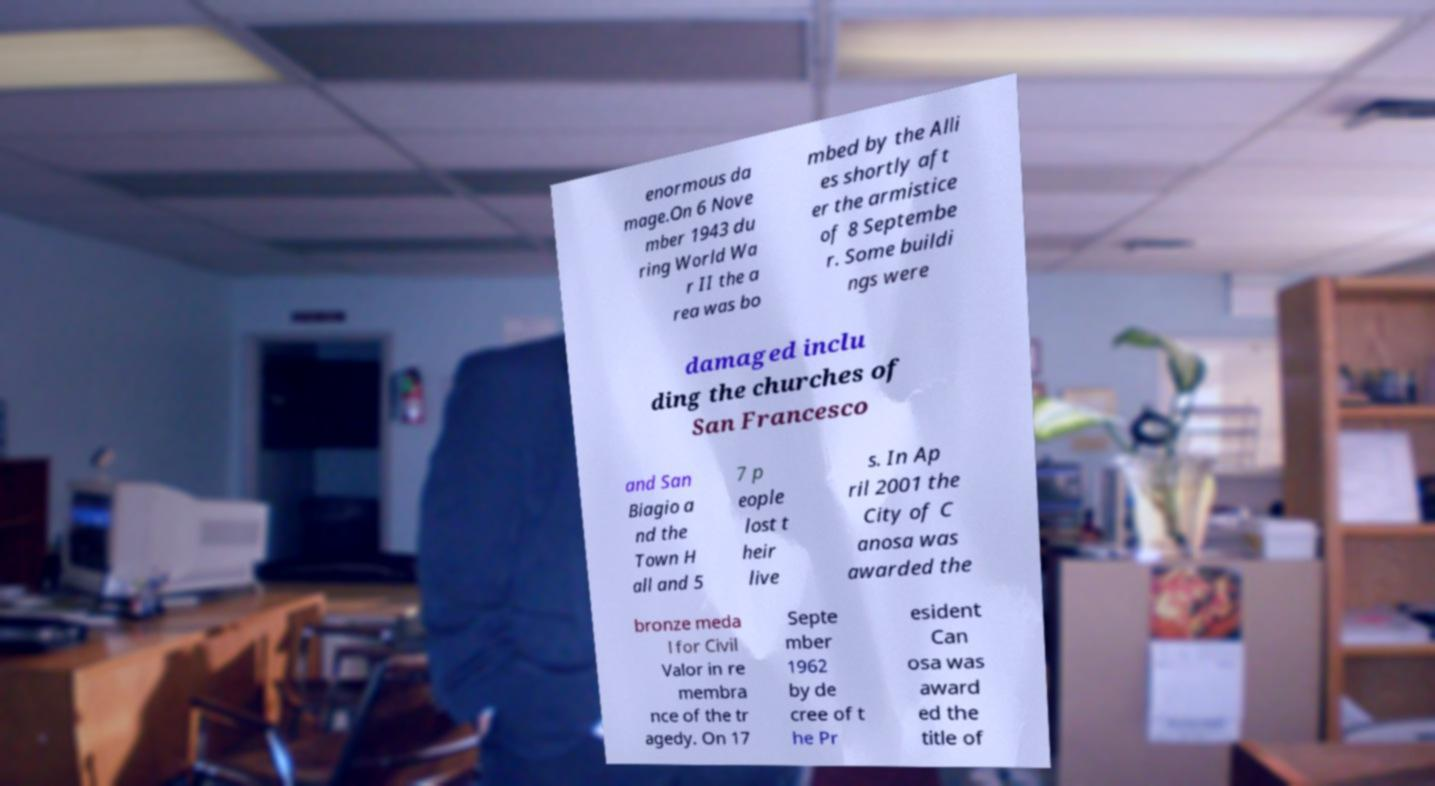There's text embedded in this image that I need extracted. Can you transcribe it verbatim? enormous da mage.On 6 Nove mber 1943 du ring World Wa r II the a rea was bo mbed by the Alli es shortly aft er the armistice of 8 Septembe r. Some buildi ngs were damaged inclu ding the churches of San Francesco and San Biagio a nd the Town H all and 5 7 p eople lost t heir live s. In Ap ril 2001 the City of C anosa was awarded the bronze meda l for Civil Valor in re membra nce of the tr agedy. On 17 Septe mber 1962 by de cree of t he Pr esident Can osa was award ed the title of 